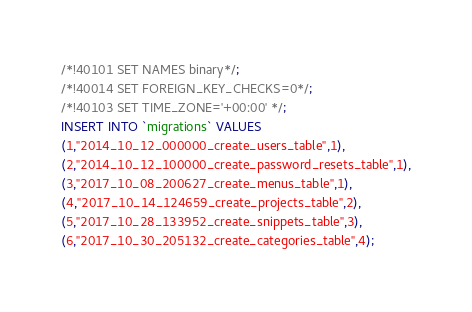<code> <loc_0><loc_0><loc_500><loc_500><_SQL_>/*!40101 SET NAMES binary*/;
/*!40014 SET FOREIGN_KEY_CHECKS=0*/;
/*!40103 SET TIME_ZONE='+00:00' */;
INSERT INTO `migrations` VALUES
(1,"2014_10_12_000000_create_users_table",1),
(2,"2014_10_12_100000_create_password_resets_table",1),
(3,"2017_10_08_200627_create_menus_table",1),
(4,"2017_10_14_124659_create_projects_table",2),
(5,"2017_10_28_133952_create_snippets_table",3),
(6,"2017_10_30_205132_create_categories_table",4);
</code> 